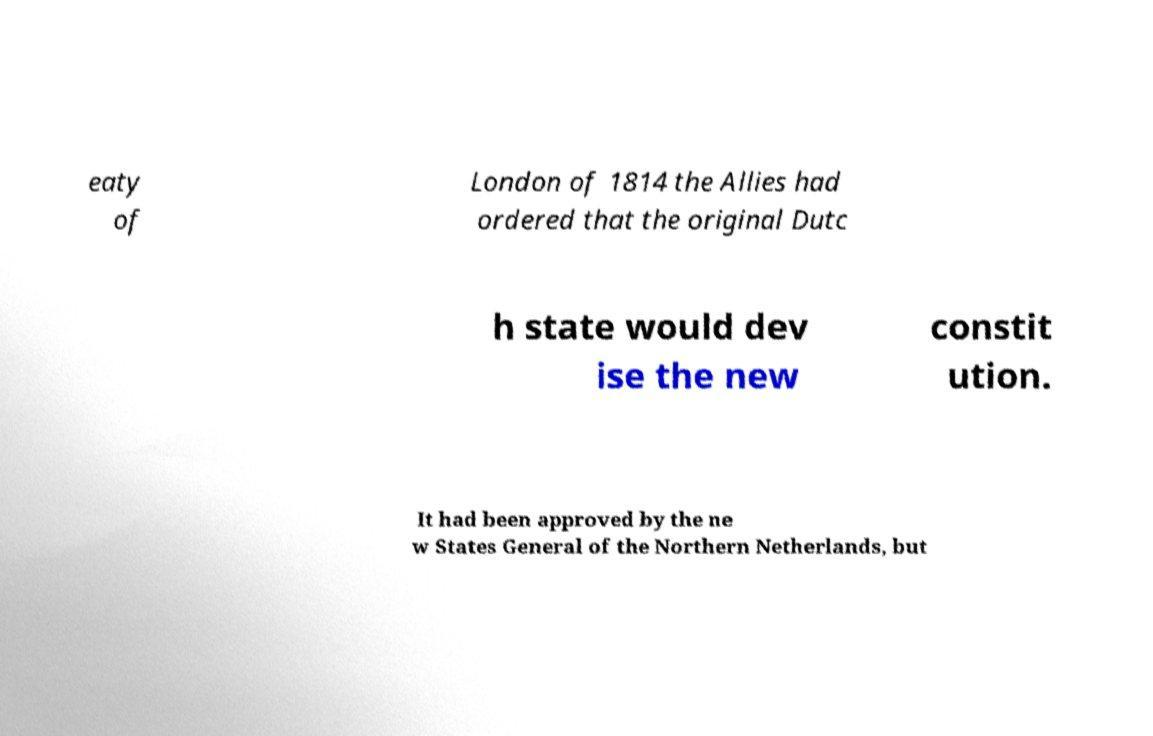What messages or text are displayed in this image? I need them in a readable, typed format. eaty of London of 1814 the Allies had ordered that the original Dutc h state would dev ise the new constit ution. It had been approved by the ne w States General of the Northern Netherlands, but 